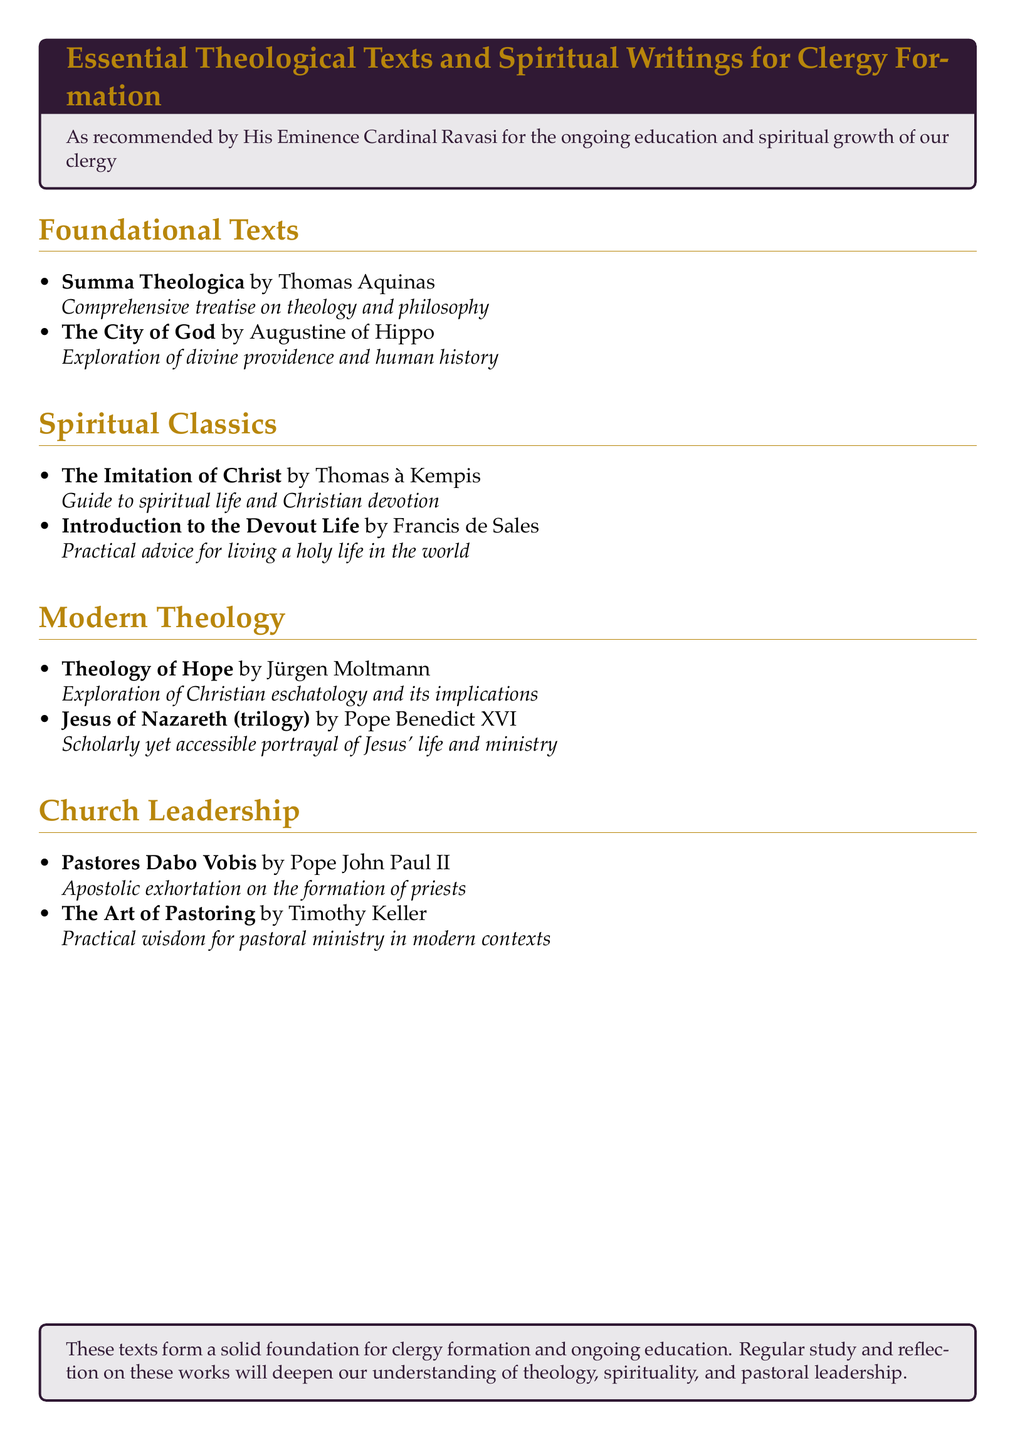What is the title of the first section? The first section is titled "Foundational Texts."
Answer: Foundational Texts How many spiritual classics are listed? There are two spiritual classics mentioned in the document.
Answer: 2 Who authored "The City of God"? The author of "The City of God" is Augustine of Hippo.
Answer: Augustine of Hippo What type of writing is "Pastores Dabo Vobis"? "Pastores Dabo Vobis" is described as an apostolic exhortation.
Answer: Apostolic exhortation Which modern theology text explores Christian eschatology? "Theology of Hope" by Jürgen Moltmann explores Christian eschatology.
Answer: Theology of Hope What is the primary focus of "The Art of Pastoring"? The primary focus of "The Art of Pastoring" is practical wisdom for pastoral ministry in modern contexts.
Answer: Practical wisdom for pastoral ministry How many total sections are included in the document? There are four sections included in the document.
Answer: 4 What is the significance of these texts according to the document? The texts form a solid foundation for clergy formation and ongoing education.
Answer: Solid foundation for clergy formation 